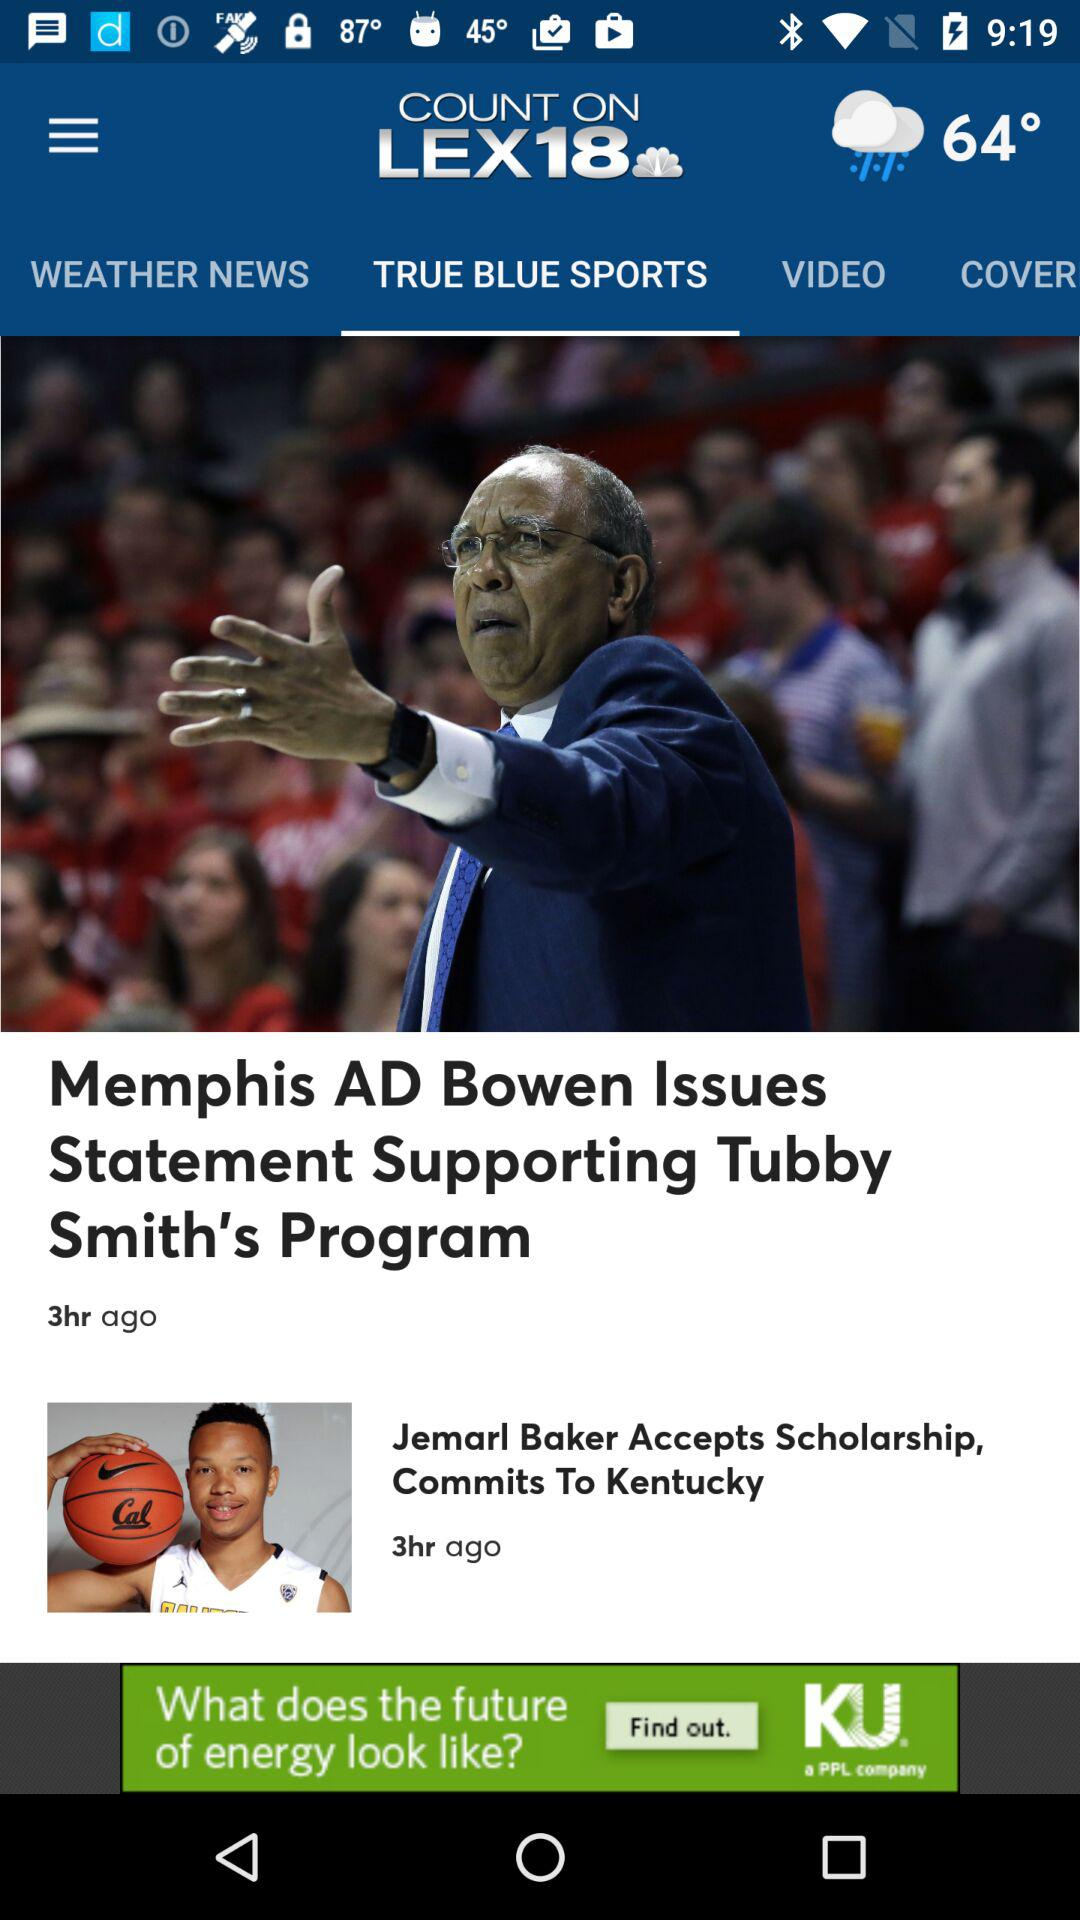How many hours ago was the Jemarl Baker article published?
Answer the question using a single word or phrase. 3 